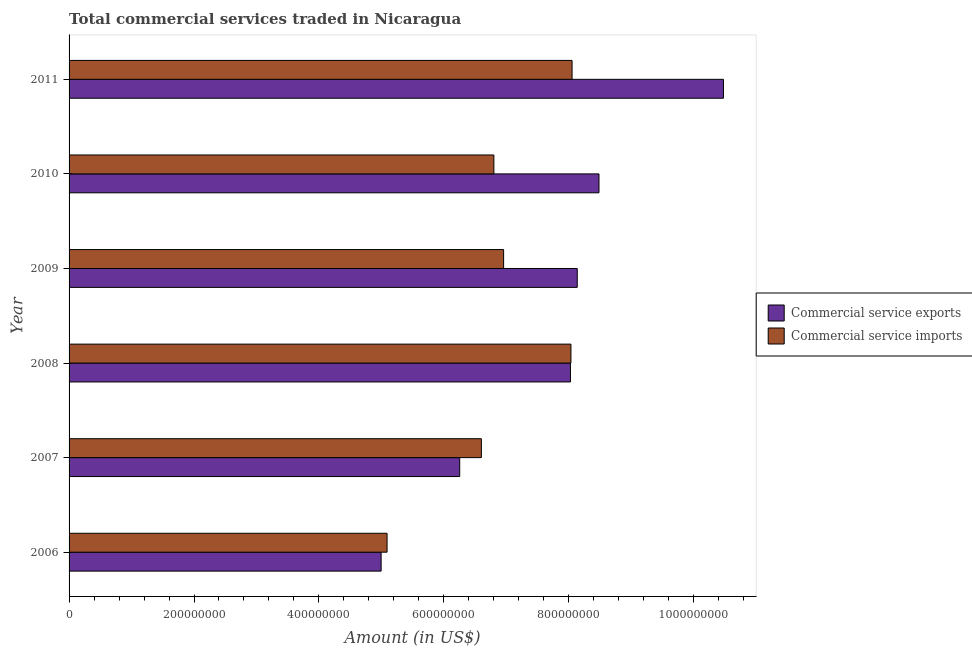How many different coloured bars are there?
Provide a short and direct response. 2. How many groups of bars are there?
Provide a succinct answer. 6. Are the number of bars per tick equal to the number of legend labels?
Your answer should be compact. Yes. How many bars are there on the 3rd tick from the bottom?
Ensure brevity in your answer.  2. What is the amount of commercial service exports in 2007?
Your answer should be very brief. 6.25e+08. Across all years, what is the maximum amount of commercial service exports?
Give a very brief answer. 1.05e+09. Across all years, what is the minimum amount of commercial service imports?
Ensure brevity in your answer.  5.09e+08. In which year was the amount of commercial service exports maximum?
Give a very brief answer. 2011. What is the total amount of commercial service imports in the graph?
Give a very brief answer. 4.15e+09. What is the difference between the amount of commercial service imports in 2009 and that in 2010?
Your answer should be compact. 1.56e+07. What is the difference between the amount of commercial service exports in 2009 and the amount of commercial service imports in 2007?
Provide a short and direct response. 1.54e+08. What is the average amount of commercial service exports per year?
Your answer should be compact. 7.73e+08. In the year 2010, what is the difference between the amount of commercial service imports and amount of commercial service exports?
Make the answer very short. -1.68e+08. Is the amount of commercial service imports in 2006 less than that in 2010?
Keep it short and to the point. Yes. Is the difference between the amount of commercial service imports in 2010 and 2011 greater than the difference between the amount of commercial service exports in 2010 and 2011?
Offer a terse response. Yes. What is the difference between the highest and the second highest amount of commercial service imports?
Give a very brief answer. 1.80e+06. What is the difference between the highest and the lowest amount of commercial service imports?
Offer a terse response. 2.96e+08. Is the sum of the amount of commercial service imports in 2009 and 2010 greater than the maximum amount of commercial service exports across all years?
Your response must be concise. Yes. What does the 2nd bar from the top in 2011 represents?
Provide a short and direct response. Commercial service exports. What does the 1st bar from the bottom in 2010 represents?
Ensure brevity in your answer.  Commercial service exports. Are all the bars in the graph horizontal?
Offer a very short reply. Yes. How many years are there in the graph?
Make the answer very short. 6. Are the values on the major ticks of X-axis written in scientific E-notation?
Ensure brevity in your answer.  No. Does the graph contain any zero values?
Your response must be concise. No. How many legend labels are there?
Keep it short and to the point. 2. What is the title of the graph?
Your answer should be very brief. Total commercial services traded in Nicaragua. Does "Techinal cooperation" appear as one of the legend labels in the graph?
Offer a terse response. No. What is the label or title of the Y-axis?
Offer a terse response. Year. What is the Amount (in US$) in Commercial service exports in 2006?
Give a very brief answer. 5.00e+08. What is the Amount (in US$) of Commercial service imports in 2006?
Keep it short and to the point. 5.09e+08. What is the Amount (in US$) of Commercial service exports in 2007?
Your response must be concise. 6.25e+08. What is the Amount (in US$) in Commercial service imports in 2007?
Your answer should be very brief. 6.60e+08. What is the Amount (in US$) of Commercial service exports in 2008?
Your response must be concise. 8.03e+08. What is the Amount (in US$) in Commercial service imports in 2008?
Provide a short and direct response. 8.04e+08. What is the Amount (in US$) in Commercial service exports in 2009?
Give a very brief answer. 8.14e+08. What is the Amount (in US$) of Commercial service imports in 2009?
Offer a very short reply. 6.96e+08. What is the Amount (in US$) of Commercial service exports in 2010?
Your response must be concise. 8.48e+08. What is the Amount (in US$) in Commercial service imports in 2010?
Offer a very short reply. 6.80e+08. What is the Amount (in US$) in Commercial service exports in 2011?
Make the answer very short. 1.05e+09. What is the Amount (in US$) of Commercial service imports in 2011?
Keep it short and to the point. 8.05e+08. Across all years, what is the maximum Amount (in US$) of Commercial service exports?
Offer a very short reply. 1.05e+09. Across all years, what is the maximum Amount (in US$) in Commercial service imports?
Offer a terse response. 8.05e+08. Across all years, what is the minimum Amount (in US$) of Commercial service exports?
Give a very brief answer. 5.00e+08. Across all years, what is the minimum Amount (in US$) in Commercial service imports?
Provide a succinct answer. 5.09e+08. What is the total Amount (in US$) of Commercial service exports in the graph?
Your answer should be very brief. 4.64e+09. What is the total Amount (in US$) of Commercial service imports in the graph?
Provide a short and direct response. 4.15e+09. What is the difference between the Amount (in US$) in Commercial service exports in 2006 and that in 2007?
Provide a succinct answer. -1.26e+08. What is the difference between the Amount (in US$) of Commercial service imports in 2006 and that in 2007?
Your answer should be compact. -1.51e+08. What is the difference between the Amount (in US$) in Commercial service exports in 2006 and that in 2008?
Your response must be concise. -3.03e+08. What is the difference between the Amount (in US$) of Commercial service imports in 2006 and that in 2008?
Give a very brief answer. -2.94e+08. What is the difference between the Amount (in US$) of Commercial service exports in 2006 and that in 2009?
Your answer should be very brief. -3.14e+08. What is the difference between the Amount (in US$) in Commercial service imports in 2006 and that in 2009?
Give a very brief answer. -1.87e+08. What is the difference between the Amount (in US$) of Commercial service exports in 2006 and that in 2010?
Your response must be concise. -3.49e+08. What is the difference between the Amount (in US$) of Commercial service imports in 2006 and that in 2010?
Provide a short and direct response. -1.71e+08. What is the difference between the Amount (in US$) in Commercial service exports in 2006 and that in 2011?
Your answer should be very brief. -5.48e+08. What is the difference between the Amount (in US$) of Commercial service imports in 2006 and that in 2011?
Make the answer very short. -2.96e+08. What is the difference between the Amount (in US$) in Commercial service exports in 2007 and that in 2008?
Give a very brief answer. -1.77e+08. What is the difference between the Amount (in US$) in Commercial service imports in 2007 and that in 2008?
Your response must be concise. -1.43e+08. What is the difference between the Amount (in US$) in Commercial service exports in 2007 and that in 2009?
Provide a succinct answer. -1.88e+08. What is the difference between the Amount (in US$) in Commercial service imports in 2007 and that in 2009?
Ensure brevity in your answer.  -3.56e+07. What is the difference between the Amount (in US$) in Commercial service exports in 2007 and that in 2010?
Your response must be concise. -2.23e+08. What is the difference between the Amount (in US$) of Commercial service imports in 2007 and that in 2010?
Give a very brief answer. -2.00e+07. What is the difference between the Amount (in US$) of Commercial service exports in 2007 and that in 2011?
Your response must be concise. -4.22e+08. What is the difference between the Amount (in US$) of Commercial service imports in 2007 and that in 2011?
Keep it short and to the point. -1.45e+08. What is the difference between the Amount (in US$) in Commercial service exports in 2008 and that in 2009?
Offer a terse response. -1.09e+07. What is the difference between the Amount (in US$) in Commercial service imports in 2008 and that in 2009?
Keep it short and to the point. 1.08e+08. What is the difference between the Amount (in US$) of Commercial service exports in 2008 and that in 2010?
Your answer should be compact. -4.57e+07. What is the difference between the Amount (in US$) of Commercial service imports in 2008 and that in 2010?
Make the answer very short. 1.23e+08. What is the difference between the Amount (in US$) in Commercial service exports in 2008 and that in 2011?
Keep it short and to the point. -2.45e+08. What is the difference between the Amount (in US$) in Commercial service imports in 2008 and that in 2011?
Your answer should be compact. -1.80e+06. What is the difference between the Amount (in US$) in Commercial service exports in 2009 and that in 2010?
Make the answer very short. -3.48e+07. What is the difference between the Amount (in US$) in Commercial service imports in 2009 and that in 2010?
Offer a very short reply. 1.56e+07. What is the difference between the Amount (in US$) of Commercial service exports in 2009 and that in 2011?
Provide a succinct answer. -2.34e+08. What is the difference between the Amount (in US$) of Commercial service imports in 2009 and that in 2011?
Offer a terse response. -1.10e+08. What is the difference between the Amount (in US$) of Commercial service exports in 2010 and that in 2011?
Offer a terse response. -1.99e+08. What is the difference between the Amount (in US$) of Commercial service imports in 2010 and that in 2011?
Offer a very short reply. -1.25e+08. What is the difference between the Amount (in US$) of Commercial service exports in 2006 and the Amount (in US$) of Commercial service imports in 2007?
Give a very brief answer. -1.60e+08. What is the difference between the Amount (in US$) of Commercial service exports in 2006 and the Amount (in US$) of Commercial service imports in 2008?
Your answer should be compact. -3.04e+08. What is the difference between the Amount (in US$) in Commercial service exports in 2006 and the Amount (in US$) in Commercial service imports in 2009?
Provide a succinct answer. -1.96e+08. What is the difference between the Amount (in US$) in Commercial service exports in 2006 and the Amount (in US$) in Commercial service imports in 2010?
Provide a short and direct response. -1.80e+08. What is the difference between the Amount (in US$) in Commercial service exports in 2006 and the Amount (in US$) in Commercial service imports in 2011?
Give a very brief answer. -3.06e+08. What is the difference between the Amount (in US$) of Commercial service exports in 2007 and the Amount (in US$) of Commercial service imports in 2008?
Provide a short and direct response. -1.78e+08. What is the difference between the Amount (in US$) in Commercial service exports in 2007 and the Amount (in US$) in Commercial service imports in 2009?
Keep it short and to the point. -7.03e+07. What is the difference between the Amount (in US$) in Commercial service exports in 2007 and the Amount (in US$) in Commercial service imports in 2010?
Your answer should be compact. -5.47e+07. What is the difference between the Amount (in US$) of Commercial service exports in 2007 and the Amount (in US$) of Commercial service imports in 2011?
Give a very brief answer. -1.80e+08. What is the difference between the Amount (in US$) in Commercial service exports in 2008 and the Amount (in US$) in Commercial service imports in 2009?
Ensure brevity in your answer.  1.07e+08. What is the difference between the Amount (in US$) in Commercial service exports in 2008 and the Amount (in US$) in Commercial service imports in 2010?
Ensure brevity in your answer.  1.23e+08. What is the difference between the Amount (in US$) of Commercial service exports in 2008 and the Amount (in US$) of Commercial service imports in 2011?
Your answer should be compact. -2.60e+06. What is the difference between the Amount (in US$) of Commercial service exports in 2009 and the Amount (in US$) of Commercial service imports in 2010?
Keep it short and to the point. 1.34e+08. What is the difference between the Amount (in US$) of Commercial service exports in 2009 and the Amount (in US$) of Commercial service imports in 2011?
Give a very brief answer. 8.30e+06. What is the difference between the Amount (in US$) in Commercial service exports in 2010 and the Amount (in US$) in Commercial service imports in 2011?
Make the answer very short. 4.31e+07. What is the average Amount (in US$) in Commercial service exports per year?
Provide a succinct answer. 7.73e+08. What is the average Amount (in US$) in Commercial service imports per year?
Provide a succinct answer. 6.92e+08. In the year 2006, what is the difference between the Amount (in US$) of Commercial service exports and Amount (in US$) of Commercial service imports?
Your answer should be very brief. -9.50e+06. In the year 2007, what is the difference between the Amount (in US$) of Commercial service exports and Amount (in US$) of Commercial service imports?
Ensure brevity in your answer.  -3.47e+07. In the year 2008, what is the difference between the Amount (in US$) in Commercial service exports and Amount (in US$) in Commercial service imports?
Offer a terse response. -8.00e+05. In the year 2009, what is the difference between the Amount (in US$) of Commercial service exports and Amount (in US$) of Commercial service imports?
Give a very brief answer. 1.18e+08. In the year 2010, what is the difference between the Amount (in US$) in Commercial service exports and Amount (in US$) in Commercial service imports?
Your response must be concise. 1.68e+08. In the year 2011, what is the difference between the Amount (in US$) of Commercial service exports and Amount (in US$) of Commercial service imports?
Ensure brevity in your answer.  2.42e+08. What is the ratio of the Amount (in US$) of Commercial service exports in 2006 to that in 2007?
Keep it short and to the point. 0.8. What is the ratio of the Amount (in US$) of Commercial service imports in 2006 to that in 2007?
Offer a very short reply. 0.77. What is the ratio of the Amount (in US$) in Commercial service exports in 2006 to that in 2008?
Make the answer very short. 0.62. What is the ratio of the Amount (in US$) in Commercial service imports in 2006 to that in 2008?
Your response must be concise. 0.63. What is the ratio of the Amount (in US$) in Commercial service exports in 2006 to that in 2009?
Give a very brief answer. 0.61. What is the ratio of the Amount (in US$) of Commercial service imports in 2006 to that in 2009?
Your response must be concise. 0.73. What is the ratio of the Amount (in US$) in Commercial service exports in 2006 to that in 2010?
Offer a very short reply. 0.59. What is the ratio of the Amount (in US$) in Commercial service imports in 2006 to that in 2010?
Make the answer very short. 0.75. What is the ratio of the Amount (in US$) of Commercial service exports in 2006 to that in 2011?
Provide a succinct answer. 0.48. What is the ratio of the Amount (in US$) in Commercial service imports in 2006 to that in 2011?
Ensure brevity in your answer.  0.63. What is the ratio of the Amount (in US$) of Commercial service exports in 2007 to that in 2008?
Your response must be concise. 0.78. What is the ratio of the Amount (in US$) in Commercial service imports in 2007 to that in 2008?
Your answer should be compact. 0.82. What is the ratio of the Amount (in US$) in Commercial service exports in 2007 to that in 2009?
Your answer should be very brief. 0.77. What is the ratio of the Amount (in US$) in Commercial service imports in 2007 to that in 2009?
Offer a terse response. 0.95. What is the ratio of the Amount (in US$) in Commercial service exports in 2007 to that in 2010?
Ensure brevity in your answer.  0.74. What is the ratio of the Amount (in US$) in Commercial service imports in 2007 to that in 2010?
Your answer should be very brief. 0.97. What is the ratio of the Amount (in US$) of Commercial service exports in 2007 to that in 2011?
Provide a short and direct response. 0.6. What is the ratio of the Amount (in US$) in Commercial service imports in 2007 to that in 2011?
Your answer should be compact. 0.82. What is the ratio of the Amount (in US$) of Commercial service exports in 2008 to that in 2009?
Provide a succinct answer. 0.99. What is the ratio of the Amount (in US$) of Commercial service imports in 2008 to that in 2009?
Your answer should be compact. 1.16. What is the ratio of the Amount (in US$) of Commercial service exports in 2008 to that in 2010?
Give a very brief answer. 0.95. What is the ratio of the Amount (in US$) of Commercial service imports in 2008 to that in 2010?
Provide a succinct answer. 1.18. What is the ratio of the Amount (in US$) of Commercial service exports in 2008 to that in 2011?
Ensure brevity in your answer.  0.77. What is the ratio of the Amount (in US$) of Commercial service imports in 2008 to that in 2011?
Make the answer very short. 1. What is the ratio of the Amount (in US$) of Commercial service exports in 2009 to that in 2010?
Make the answer very short. 0.96. What is the ratio of the Amount (in US$) in Commercial service imports in 2009 to that in 2010?
Give a very brief answer. 1.02. What is the ratio of the Amount (in US$) in Commercial service exports in 2009 to that in 2011?
Keep it short and to the point. 0.78. What is the ratio of the Amount (in US$) of Commercial service imports in 2009 to that in 2011?
Give a very brief answer. 0.86. What is the ratio of the Amount (in US$) in Commercial service exports in 2010 to that in 2011?
Ensure brevity in your answer.  0.81. What is the ratio of the Amount (in US$) in Commercial service imports in 2010 to that in 2011?
Provide a short and direct response. 0.84. What is the difference between the highest and the second highest Amount (in US$) in Commercial service exports?
Give a very brief answer. 1.99e+08. What is the difference between the highest and the second highest Amount (in US$) in Commercial service imports?
Keep it short and to the point. 1.80e+06. What is the difference between the highest and the lowest Amount (in US$) in Commercial service exports?
Your answer should be very brief. 5.48e+08. What is the difference between the highest and the lowest Amount (in US$) in Commercial service imports?
Ensure brevity in your answer.  2.96e+08. 